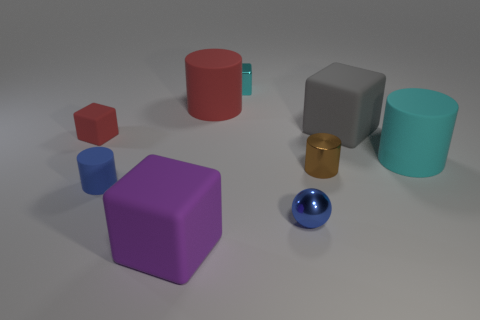There is a large gray object that is the same material as the large red cylinder; what shape is it?
Your answer should be compact. Cube. What number of other objects are there of the same shape as the tiny cyan thing?
Offer a very short reply. 3. The small matte object that is in front of the cyan rubber object has what shape?
Provide a succinct answer. Cylinder. What color is the metallic cylinder?
Your response must be concise. Brown. What number of other things are the same size as the blue rubber thing?
Ensure brevity in your answer.  4. There is a big cube that is in front of the small block that is in front of the cyan block; what is it made of?
Offer a very short reply. Rubber. There is a brown shiny object; is it the same size as the blue thing that is right of the tiny cyan metallic cube?
Make the answer very short. Yes. Is there a matte cylinder of the same color as the tiny metallic cube?
Your answer should be compact. Yes. What number of small objects are brown things or purple metallic blocks?
Your response must be concise. 1. What number of green matte balls are there?
Offer a very short reply. 0. 